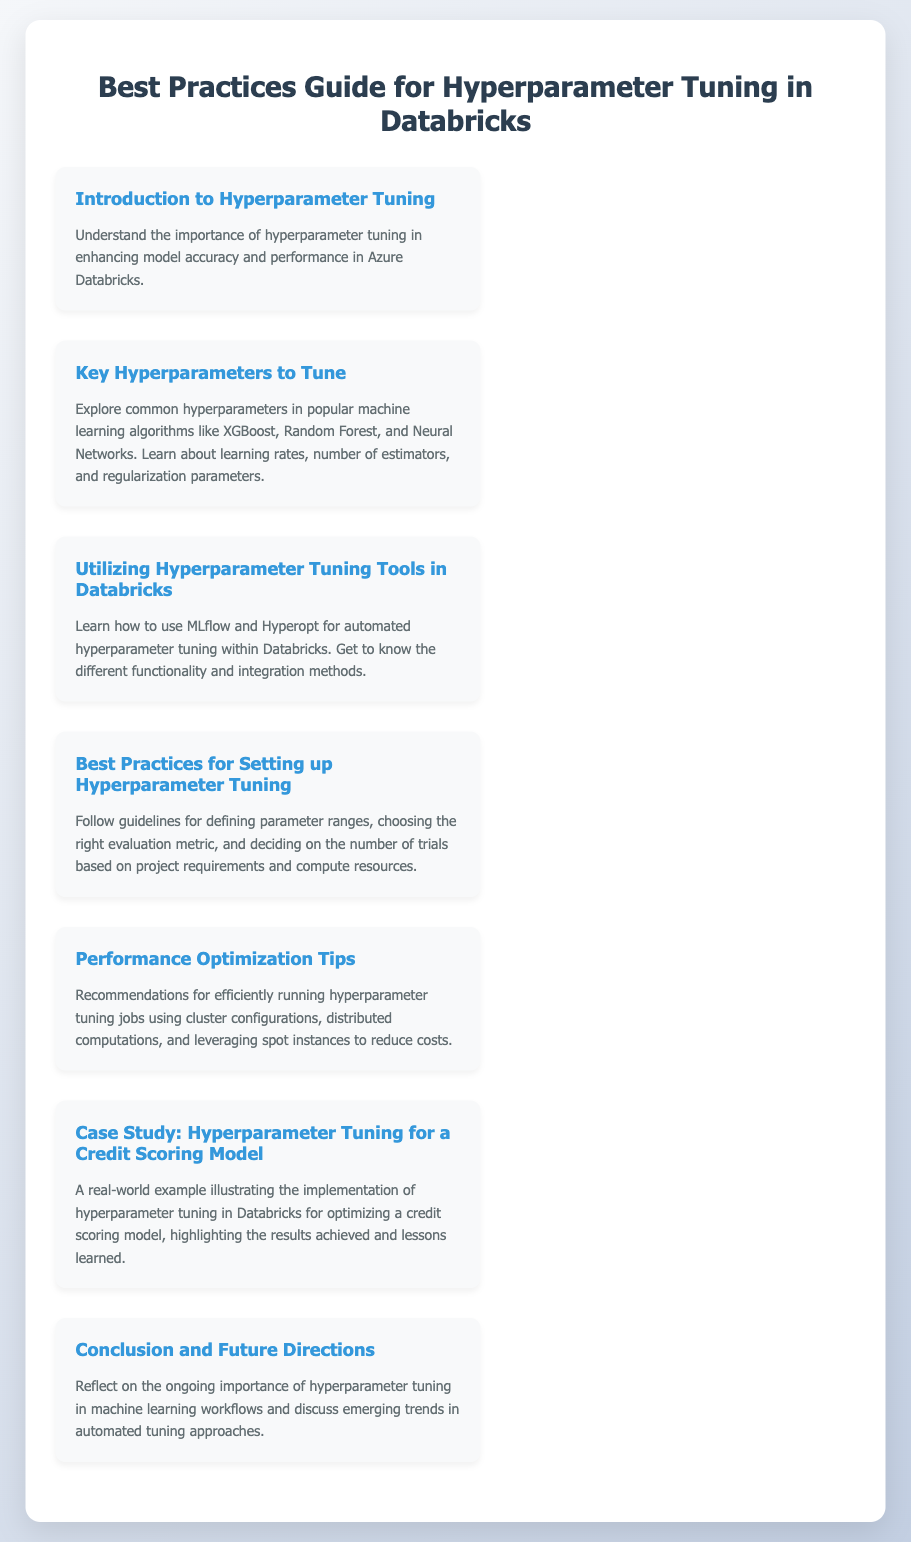What is the title of the document? The title is prominently displayed at the top of the document, stating the focus on hyperparameter tuning in Databricks.
Answer: Best Practices Guide for Hyperparameter Tuning in Databricks How many case studies are mentioned in the document? The document includes a specific section dedicated to a case study, providing a detailed example of application.
Answer: 1 What is the focus of the "Key Hyperparameters to Tune" section? This section describes common hyperparameters found in various algorithms, highlighting the importance of specific parameters for tuning.
Answer: Learning rates, number of estimators, and regularization parameters Which tool is recommended for automated hyperparameter tuning in Databricks? The document specifies certain tools that facilitate automation in hyperparameter tuning, focusing on MLflow and Hyperopt.
Answer: MLflow and Hyperopt What is emphasized in the "Performance Optimization Tips"? This section contains practical recommendations to improve efficiency while performing tuning jobs, reflecting on resource management.
Answer: Cluster configurations, distributed computations, and leveraging spot instances 